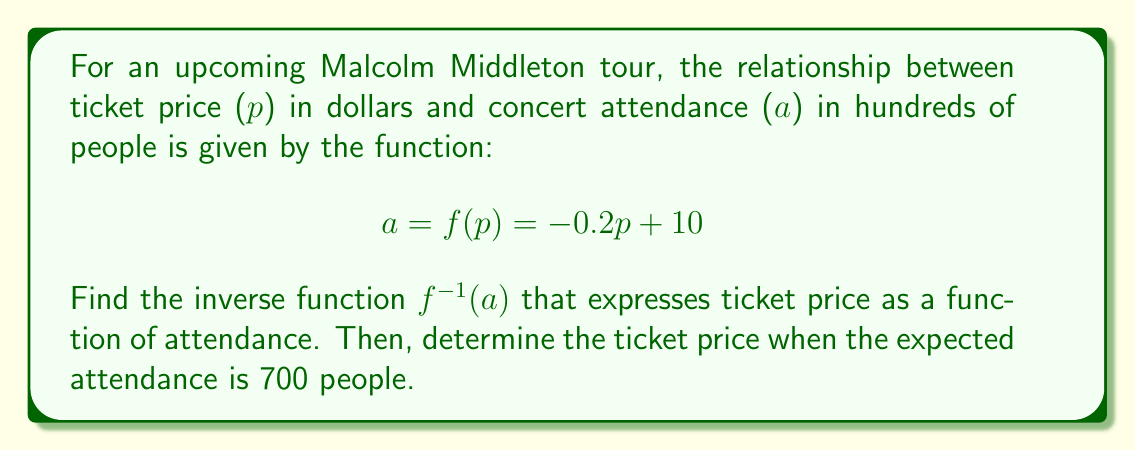Help me with this question. To find the inverse function, we follow these steps:

1) Start with the original function:
   $$a = -0.2p + 10$$

2) Swap a and p:
   $$p = -0.2a + 10$$

3) Solve for a:
   $$p + 0.2a = 10$$
   $$0.2a = 10 - p$$
   $$a = \frac{10 - p}{0.2}$$

4) Simplify:
   $$a = 50 - 5p$$

5) Therefore, the inverse function is:
   $$p = f^{-1}(a) = 10 - 0.2a$$

To find the ticket price when attendance is 700 people:

6) Convert 700 people to hundreds: $a = 7$

7) Substitute into the inverse function:
   $$p = 10 - 0.2(7) = 10 - 1.4 = 8.6$$

Thus, the ticket price should be $8.60 when the expected attendance is 700 people.
Answer: The inverse function is $f^{-1}(a) = 10 - 0.2a$, and the ticket price for an expected attendance of 700 people is $8.60. 